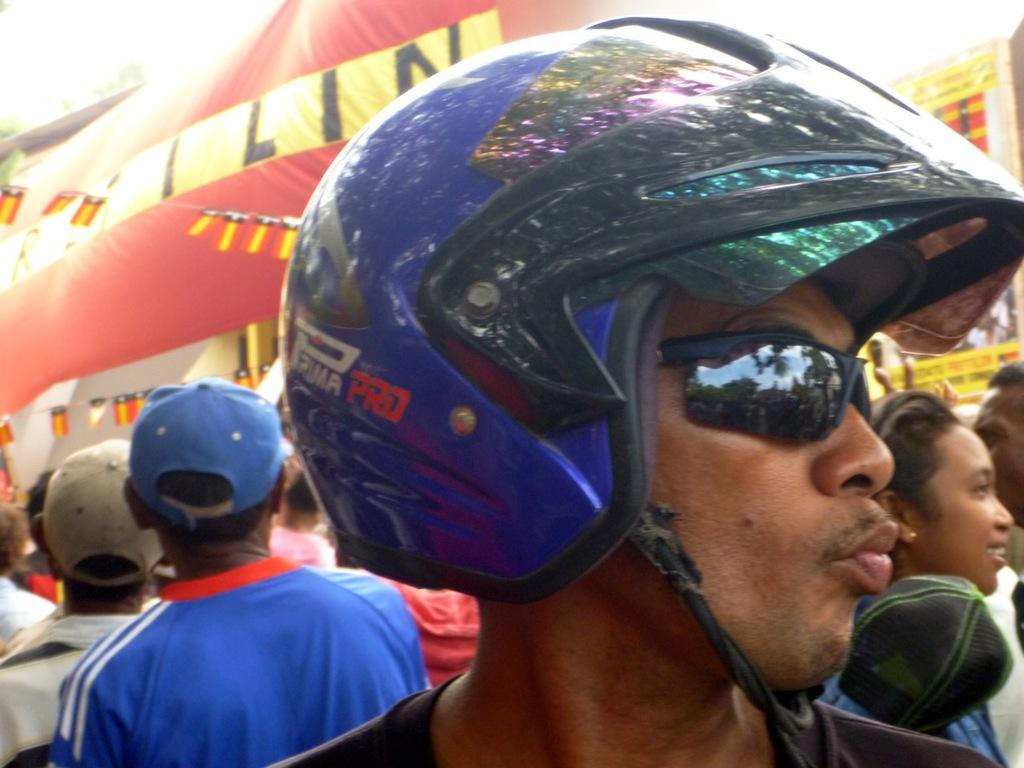Who is present in the image? There is a person in the image. What protective gear is the person wearing? The person is wearing a helmet. What type of eyewear is the person wearing? The person is wearing spectacles. What can be seen in the background of the image? There is a crowd and tents in the background of the image. How many eggs are being served at the person's birthday party in the image? There is no indication of a birthday party or eggs in the image. 